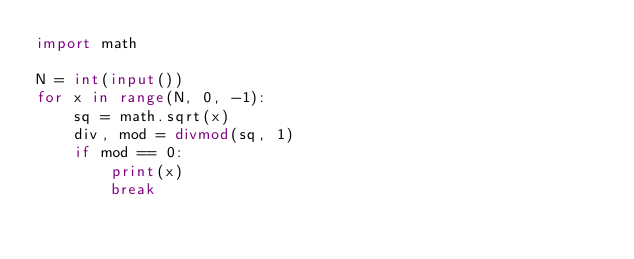Convert code to text. <code><loc_0><loc_0><loc_500><loc_500><_Python_>import math

N = int(input())
for x in range(N, 0, -1):
    sq = math.sqrt(x)
    div, mod = divmod(sq, 1)
    if mod == 0:
        print(x)
        break
</code> 